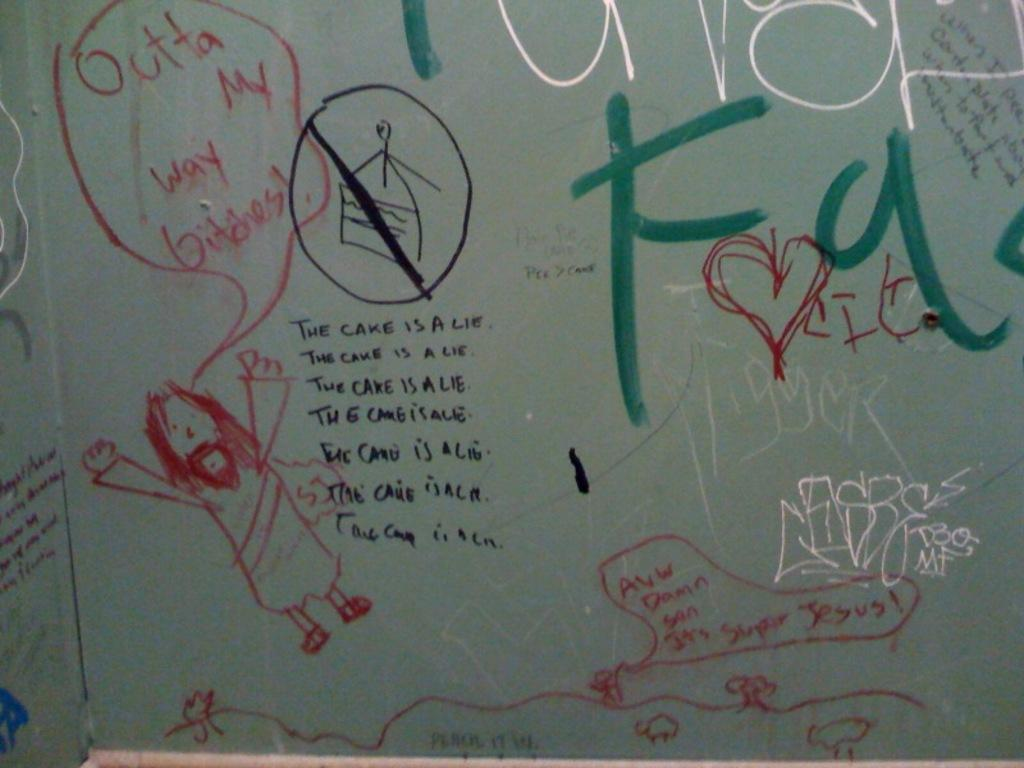<image>
Present a compact description of the photo's key features. On a white wall, circled in red Outta My Way Bitches! 